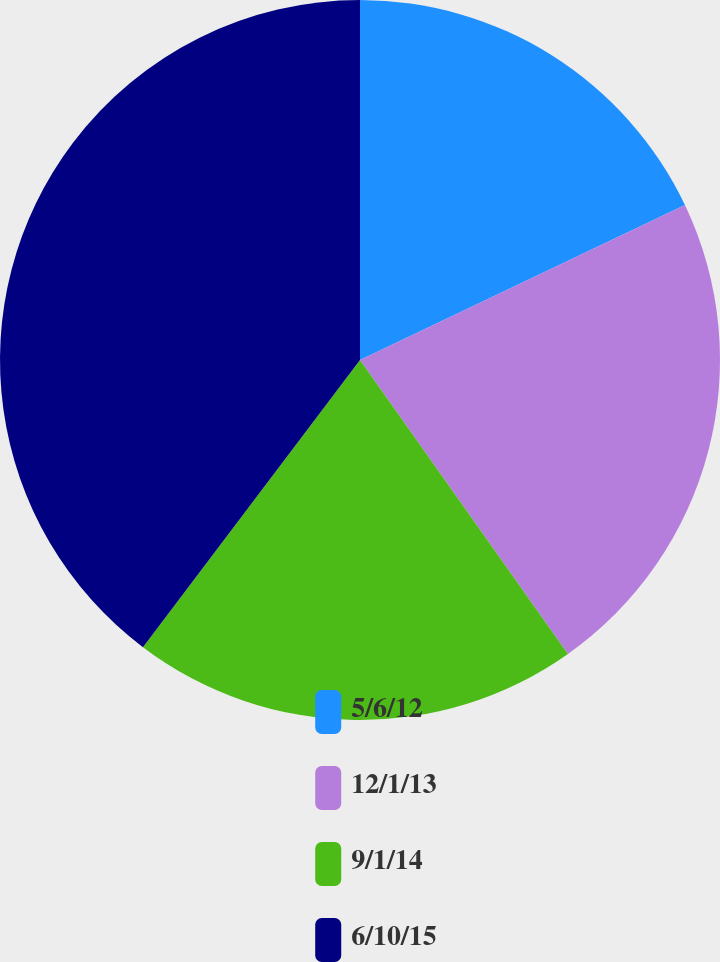Convert chart. <chart><loc_0><loc_0><loc_500><loc_500><pie_chart><fcel>5/6/12<fcel>12/1/13<fcel>9/1/14<fcel>6/10/15<nl><fcel>17.92%<fcel>22.28%<fcel>20.1%<fcel>39.7%<nl></chart> 